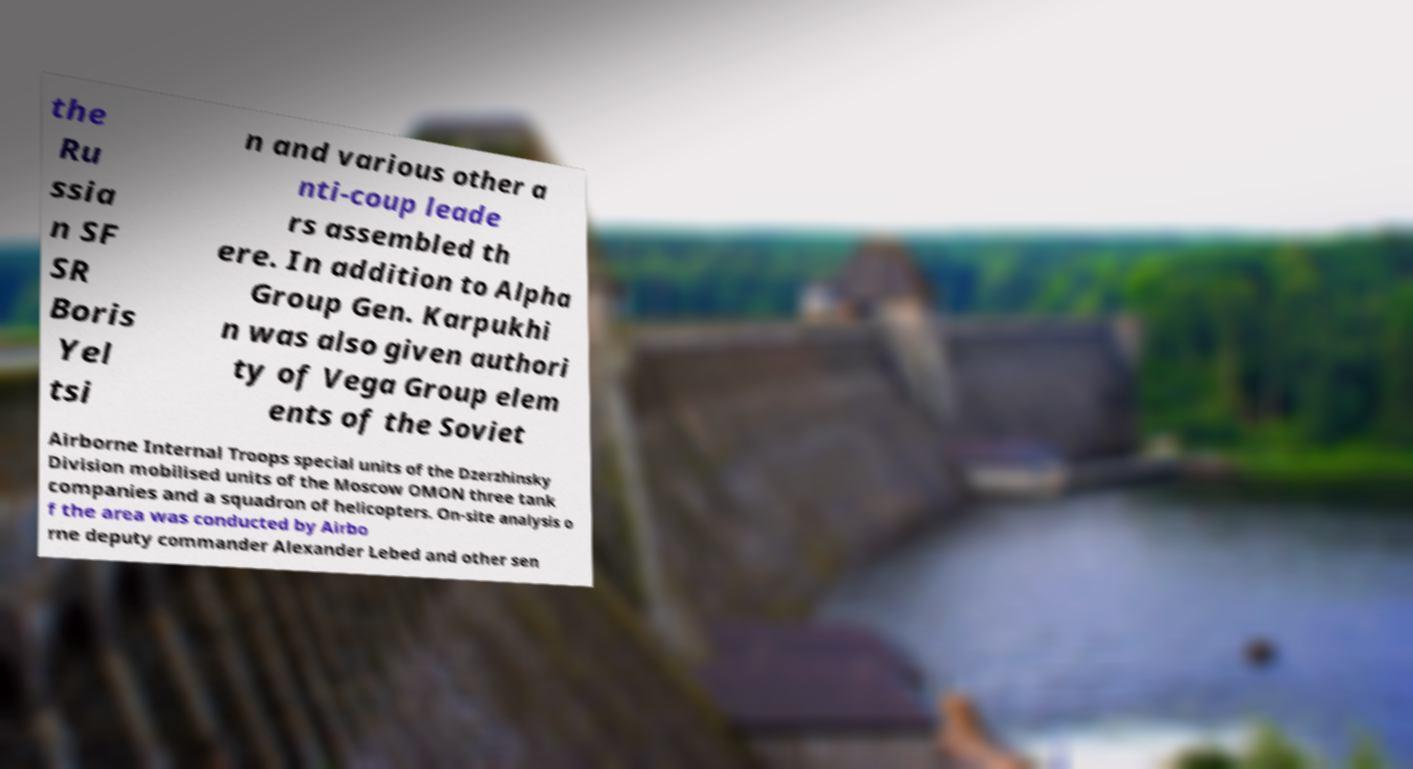Please read and relay the text visible in this image. What does it say? the Ru ssia n SF SR Boris Yel tsi n and various other a nti-coup leade rs assembled th ere. In addition to Alpha Group Gen. Karpukhi n was also given authori ty of Vega Group elem ents of the Soviet Airborne Internal Troops special units of the Dzerzhinsky Division mobilised units of the Moscow OMON three tank companies and a squadron of helicopters. On-site analysis o f the area was conducted by Airbo rne deputy commander Alexander Lebed and other sen 